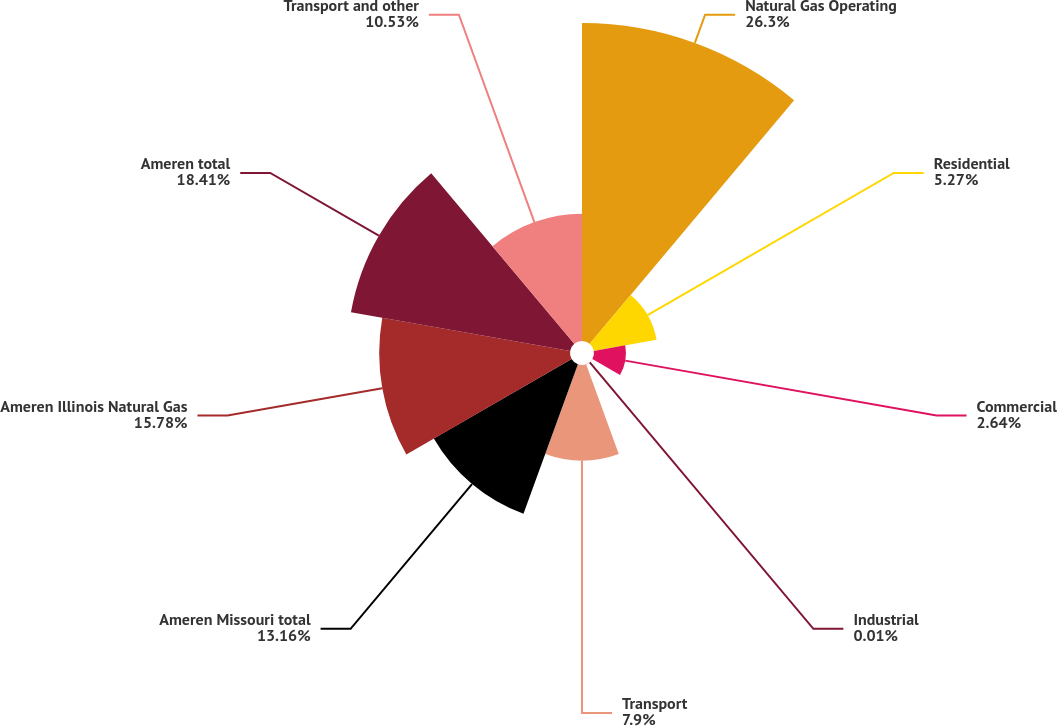<chart> <loc_0><loc_0><loc_500><loc_500><pie_chart><fcel>Natural Gas Operating<fcel>Residential<fcel>Commercial<fcel>Industrial<fcel>Transport<fcel>Ameren Missouri total<fcel>Ameren Illinois Natural Gas<fcel>Ameren total<fcel>Transport and other<nl><fcel>26.3%<fcel>5.27%<fcel>2.64%<fcel>0.01%<fcel>7.9%<fcel>13.16%<fcel>15.78%<fcel>18.41%<fcel>10.53%<nl></chart> 